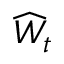<formula> <loc_0><loc_0><loc_500><loc_500>\widehat { W } _ { t }</formula> 